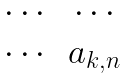Convert formula to latex. <formula><loc_0><loc_0><loc_500><loc_500>\begin{matrix} \cdots & \cdots \\ \cdots & a _ { k , n } \end{matrix}</formula> 